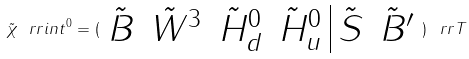Convert formula to latex. <formula><loc_0><loc_0><loc_500><loc_500>\tilde { \chi } _ { \ } r r { i n t } ^ { 0 } = ( \begin{array} { c c c c | c c } \tilde { B } & \tilde { W } ^ { 3 } & \tilde { H } _ { d } ^ { 0 } & \tilde { H } _ { u } ^ { 0 } & \tilde { S } & \tilde { B } ^ { \prime } \end{array} ) ^ { \ } r r { T }</formula> 